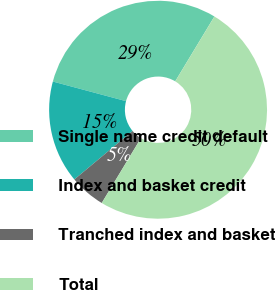<chart> <loc_0><loc_0><loc_500><loc_500><pie_chart><fcel>Single name credit default<fcel>Index and basket credit<fcel>Tranched index and basket<fcel>Total<nl><fcel>29.48%<fcel>15.22%<fcel>5.3%<fcel>50.0%<nl></chart> 